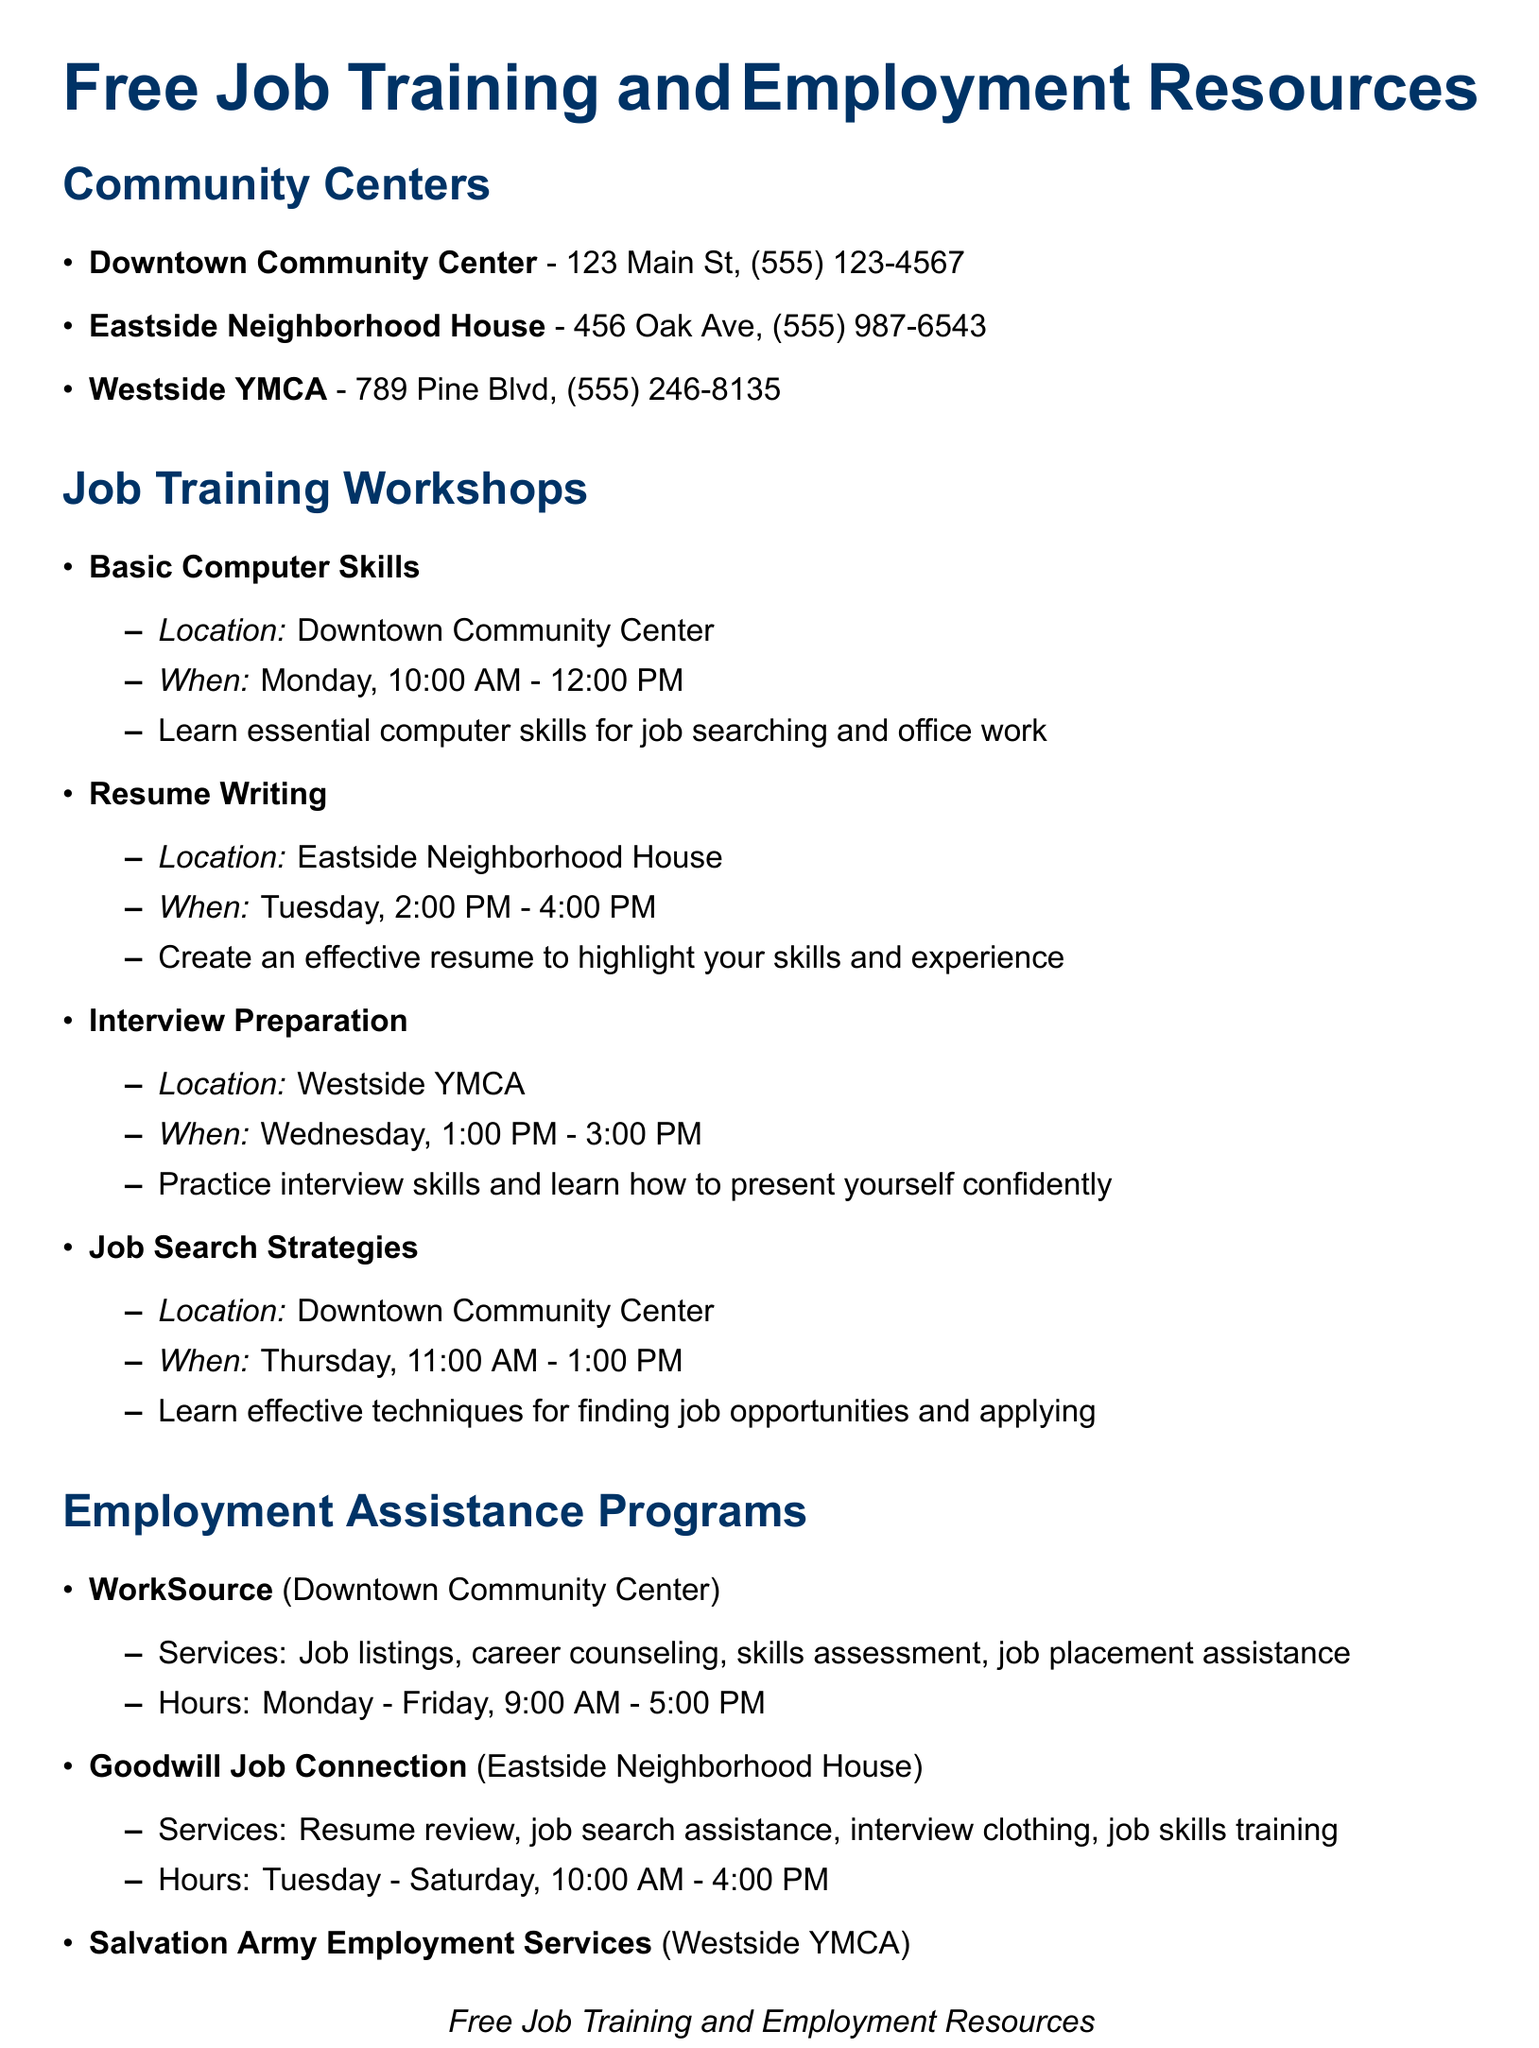what is the address of the Downtown Community Center? The address of the Downtown Community Center is listed in the document.
Answer: 123 Main St when does the Resume Writing workshop take place? The schedule indicates the day and time for the Resume Writing workshop.
Answer: Tuesday, 2:00 PM - 4:00 PM what services does Goodwill Job Connection offer? The services offered by Goodwill Job Connection are specified in the employment assistance section.
Answer: Resume review, job search assistance, interview clothing, job skills training which community center provides Job Search Strategies workshop? The document lists the location for each workshop, including Job Search Strategies.
Answer: Downtown Community Center how many days a week is WorkSource open? The operating hours of WorkSource indicate how many days per week it is open.
Answer: 5 days who should you ask for referral information regarding Dress for Success? The document specifies who to ask for referral information regarding Dress for Success.
Answer: Community centers 